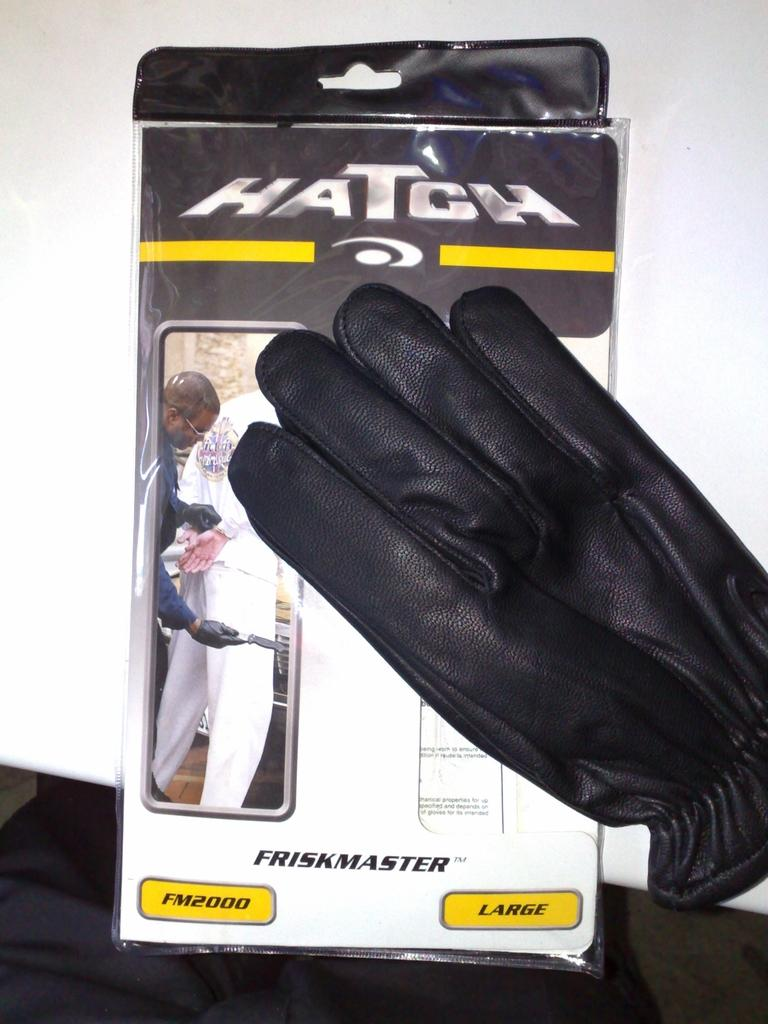What object is present in the image that is made of plastic? There is a plastic box in the image. What type of clothing item can be seen in the image? There are gloves in the image. Where are the plastic box and gloves located in the image? Both the plastic box and gloves are on a table. How many quince are being used to hold the gloves in the image? There are no quince present in the image; the gloves are not being held by any quince. 